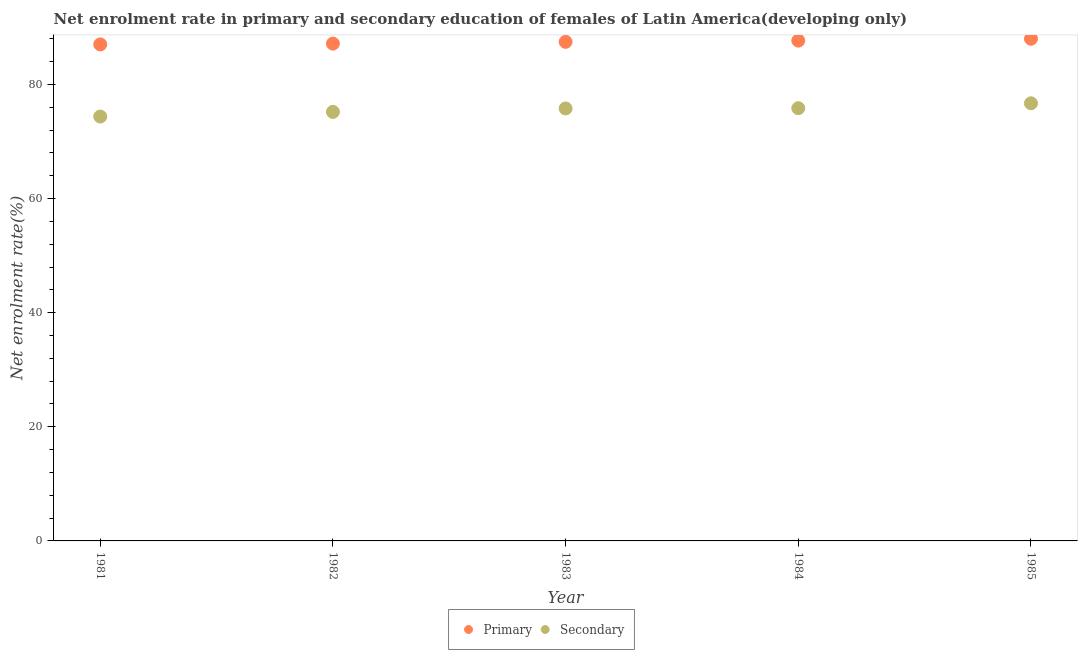Is the number of dotlines equal to the number of legend labels?
Make the answer very short. Yes. What is the enrollment rate in primary education in 1983?
Your response must be concise. 87.46. Across all years, what is the maximum enrollment rate in secondary education?
Provide a succinct answer. 76.69. Across all years, what is the minimum enrollment rate in primary education?
Offer a terse response. 87.01. In which year was the enrollment rate in primary education maximum?
Offer a terse response. 1985. In which year was the enrollment rate in secondary education minimum?
Your response must be concise. 1981. What is the total enrollment rate in secondary education in the graph?
Your answer should be very brief. 377.87. What is the difference between the enrollment rate in primary education in 1982 and that in 1983?
Ensure brevity in your answer.  -0.31. What is the difference between the enrollment rate in primary education in 1982 and the enrollment rate in secondary education in 1983?
Your response must be concise. 11.36. What is the average enrollment rate in primary education per year?
Provide a short and direct response. 87.46. In the year 1982, what is the difference between the enrollment rate in primary education and enrollment rate in secondary education?
Ensure brevity in your answer.  11.96. What is the ratio of the enrollment rate in secondary education in 1981 to that in 1983?
Give a very brief answer. 0.98. Is the enrollment rate in secondary education in 1981 less than that in 1982?
Make the answer very short. Yes. What is the difference between the highest and the second highest enrollment rate in secondary education?
Your response must be concise. 0.86. What is the difference between the highest and the lowest enrollment rate in secondary education?
Offer a very short reply. 2.32. In how many years, is the enrollment rate in primary education greater than the average enrollment rate in primary education taken over all years?
Keep it short and to the point. 3. Is the sum of the enrollment rate in secondary education in 1981 and 1985 greater than the maximum enrollment rate in primary education across all years?
Give a very brief answer. Yes. Does the enrollment rate in primary education monotonically increase over the years?
Keep it short and to the point. Yes. Is the enrollment rate in primary education strictly greater than the enrollment rate in secondary education over the years?
Keep it short and to the point. Yes. Is the enrollment rate in secondary education strictly less than the enrollment rate in primary education over the years?
Offer a very short reply. Yes. What is the difference between two consecutive major ticks on the Y-axis?
Provide a short and direct response. 20. Are the values on the major ticks of Y-axis written in scientific E-notation?
Give a very brief answer. No. Does the graph contain any zero values?
Ensure brevity in your answer.  No. Where does the legend appear in the graph?
Keep it short and to the point. Bottom center. What is the title of the graph?
Your answer should be very brief. Net enrolment rate in primary and secondary education of females of Latin America(developing only). What is the label or title of the X-axis?
Your answer should be very brief. Year. What is the label or title of the Y-axis?
Keep it short and to the point. Net enrolment rate(%). What is the Net enrolment rate(%) of Primary in 1981?
Give a very brief answer. 87.01. What is the Net enrolment rate(%) in Secondary in 1981?
Make the answer very short. 74.37. What is the Net enrolment rate(%) of Primary in 1982?
Provide a short and direct response. 87.15. What is the Net enrolment rate(%) in Secondary in 1982?
Provide a short and direct response. 75.19. What is the Net enrolment rate(%) of Primary in 1983?
Offer a very short reply. 87.46. What is the Net enrolment rate(%) in Secondary in 1983?
Offer a very short reply. 75.79. What is the Net enrolment rate(%) of Primary in 1984?
Your answer should be compact. 87.67. What is the Net enrolment rate(%) of Secondary in 1984?
Make the answer very short. 75.83. What is the Net enrolment rate(%) of Primary in 1985?
Offer a terse response. 88. What is the Net enrolment rate(%) of Secondary in 1985?
Make the answer very short. 76.69. Across all years, what is the maximum Net enrolment rate(%) in Primary?
Your response must be concise. 88. Across all years, what is the maximum Net enrolment rate(%) in Secondary?
Make the answer very short. 76.69. Across all years, what is the minimum Net enrolment rate(%) of Primary?
Give a very brief answer. 87.01. Across all years, what is the minimum Net enrolment rate(%) in Secondary?
Offer a terse response. 74.37. What is the total Net enrolment rate(%) of Primary in the graph?
Provide a succinct answer. 437.31. What is the total Net enrolment rate(%) in Secondary in the graph?
Your answer should be very brief. 377.87. What is the difference between the Net enrolment rate(%) of Primary in 1981 and that in 1982?
Give a very brief answer. -0.14. What is the difference between the Net enrolment rate(%) in Secondary in 1981 and that in 1982?
Ensure brevity in your answer.  -0.82. What is the difference between the Net enrolment rate(%) of Primary in 1981 and that in 1983?
Keep it short and to the point. -0.45. What is the difference between the Net enrolment rate(%) in Secondary in 1981 and that in 1983?
Make the answer very short. -1.42. What is the difference between the Net enrolment rate(%) in Primary in 1981 and that in 1984?
Your answer should be compact. -0.66. What is the difference between the Net enrolment rate(%) of Secondary in 1981 and that in 1984?
Provide a succinct answer. -1.46. What is the difference between the Net enrolment rate(%) in Primary in 1981 and that in 1985?
Offer a terse response. -0.99. What is the difference between the Net enrolment rate(%) in Secondary in 1981 and that in 1985?
Give a very brief answer. -2.32. What is the difference between the Net enrolment rate(%) of Primary in 1982 and that in 1983?
Provide a short and direct response. -0.31. What is the difference between the Net enrolment rate(%) of Secondary in 1982 and that in 1983?
Your response must be concise. -0.6. What is the difference between the Net enrolment rate(%) in Primary in 1982 and that in 1984?
Make the answer very short. -0.52. What is the difference between the Net enrolment rate(%) in Secondary in 1982 and that in 1984?
Ensure brevity in your answer.  -0.65. What is the difference between the Net enrolment rate(%) in Primary in 1982 and that in 1985?
Your response must be concise. -0.85. What is the difference between the Net enrolment rate(%) in Secondary in 1982 and that in 1985?
Give a very brief answer. -1.5. What is the difference between the Net enrolment rate(%) of Primary in 1983 and that in 1984?
Make the answer very short. -0.21. What is the difference between the Net enrolment rate(%) in Secondary in 1983 and that in 1984?
Your answer should be compact. -0.04. What is the difference between the Net enrolment rate(%) in Primary in 1983 and that in 1985?
Provide a succinct answer. -0.54. What is the difference between the Net enrolment rate(%) of Secondary in 1983 and that in 1985?
Your response must be concise. -0.9. What is the difference between the Net enrolment rate(%) in Primary in 1984 and that in 1985?
Offer a terse response. -0.33. What is the difference between the Net enrolment rate(%) in Secondary in 1984 and that in 1985?
Your answer should be compact. -0.86. What is the difference between the Net enrolment rate(%) in Primary in 1981 and the Net enrolment rate(%) in Secondary in 1982?
Your response must be concise. 11.83. What is the difference between the Net enrolment rate(%) in Primary in 1981 and the Net enrolment rate(%) in Secondary in 1983?
Offer a terse response. 11.22. What is the difference between the Net enrolment rate(%) in Primary in 1981 and the Net enrolment rate(%) in Secondary in 1984?
Give a very brief answer. 11.18. What is the difference between the Net enrolment rate(%) of Primary in 1981 and the Net enrolment rate(%) of Secondary in 1985?
Offer a very short reply. 10.32. What is the difference between the Net enrolment rate(%) of Primary in 1982 and the Net enrolment rate(%) of Secondary in 1983?
Provide a succinct answer. 11.36. What is the difference between the Net enrolment rate(%) in Primary in 1982 and the Net enrolment rate(%) in Secondary in 1984?
Make the answer very short. 11.32. What is the difference between the Net enrolment rate(%) of Primary in 1982 and the Net enrolment rate(%) of Secondary in 1985?
Your answer should be compact. 10.46. What is the difference between the Net enrolment rate(%) in Primary in 1983 and the Net enrolment rate(%) in Secondary in 1984?
Provide a succinct answer. 11.63. What is the difference between the Net enrolment rate(%) of Primary in 1983 and the Net enrolment rate(%) of Secondary in 1985?
Offer a terse response. 10.77. What is the difference between the Net enrolment rate(%) in Primary in 1984 and the Net enrolment rate(%) in Secondary in 1985?
Provide a short and direct response. 10.98. What is the average Net enrolment rate(%) in Primary per year?
Your response must be concise. 87.46. What is the average Net enrolment rate(%) in Secondary per year?
Offer a very short reply. 75.57. In the year 1981, what is the difference between the Net enrolment rate(%) of Primary and Net enrolment rate(%) of Secondary?
Make the answer very short. 12.64. In the year 1982, what is the difference between the Net enrolment rate(%) of Primary and Net enrolment rate(%) of Secondary?
Offer a very short reply. 11.96. In the year 1983, what is the difference between the Net enrolment rate(%) of Primary and Net enrolment rate(%) of Secondary?
Provide a short and direct response. 11.67. In the year 1984, what is the difference between the Net enrolment rate(%) of Primary and Net enrolment rate(%) of Secondary?
Keep it short and to the point. 11.84. In the year 1985, what is the difference between the Net enrolment rate(%) in Primary and Net enrolment rate(%) in Secondary?
Offer a very short reply. 11.31. What is the ratio of the Net enrolment rate(%) in Primary in 1981 to that in 1982?
Offer a very short reply. 1. What is the ratio of the Net enrolment rate(%) in Primary in 1981 to that in 1983?
Give a very brief answer. 0.99. What is the ratio of the Net enrolment rate(%) of Secondary in 1981 to that in 1983?
Provide a succinct answer. 0.98. What is the ratio of the Net enrolment rate(%) of Primary in 1981 to that in 1984?
Ensure brevity in your answer.  0.99. What is the ratio of the Net enrolment rate(%) of Secondary in 1981 to that in 1984?
Give a very brief answer. 0.98. What is the ratio of the Net enrolment rate(%) in Secondary in 1981 to that in 1985?
Give a very brief answer. 0.97. What is the ratio of the Net enrolment rate(%) of Primary in 1982 to that in 1983?
Offer a terse response. 1. What is the ratio of the Net enrolment rate(%) of Primary in 1982 to that in 1985?
Your answer should be compact. 0.99. What is the ratio of the Net enrolment rate(%) in Secondary in 1982 to that in 1985?
Offer a very short reply. 0.98. What is the ratio of the Net enrolment rate(%) of Primary in 1983 to that in 1984?
Ensure brevity in your answer.  1. What is the ratio of the Net enrolment rate(%) in Secondary in 1983 to that in 1985?
Keep it short and to the point. 0.99. What is the ratio of the Net enrolment rate(%) in Secondary in 1984 to that in 1985?
Provide a short and direct response. 0.99. What is the difference between the highest and the second highest Net enrolment rate(%) of Primary?
Provide a succinct answer. 0.33. What is the difference between the highest and the second highest Net enrolment rate(%) in Secondary?
Offer a very short reply. 0.86. What is the difference between the highest and the lowest Net enrolment rate(%) of Primary?
Give a very brief answer. 0.99. What is the difference between the highest and the lowest Net enrolment rate(%) of Secondary?
Offer a terse response. 2.32. 